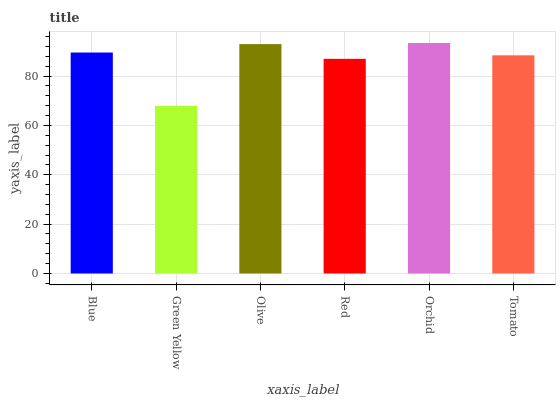Is Green Yellow the minimum?
Answer yes or no. Yes. Is Orchid the maximum?
Answer yes or no. Yes. Is Olive the minimum?
Answer yes or no. No. Is Olive the maximum?
Answer yes or no. No. Is Olive greater than Green Yellow?
Answer yes or no. Yes. Is Green Yellow less than Olive?
Answer yes or no. Yes. Is Green Yellow greater than Olive?
Answer yes or no. No. Is Olive less than Green Yellow?
Answer yes or no. No. Is Blue the high median?
Answer yes or no. Yes. Is Tomato the low median?
Answer yes or no. Yes. Is Green Yellow the high median?
Answer yes or no. No. Is Olive the low median?
Answer yes or no. No. 